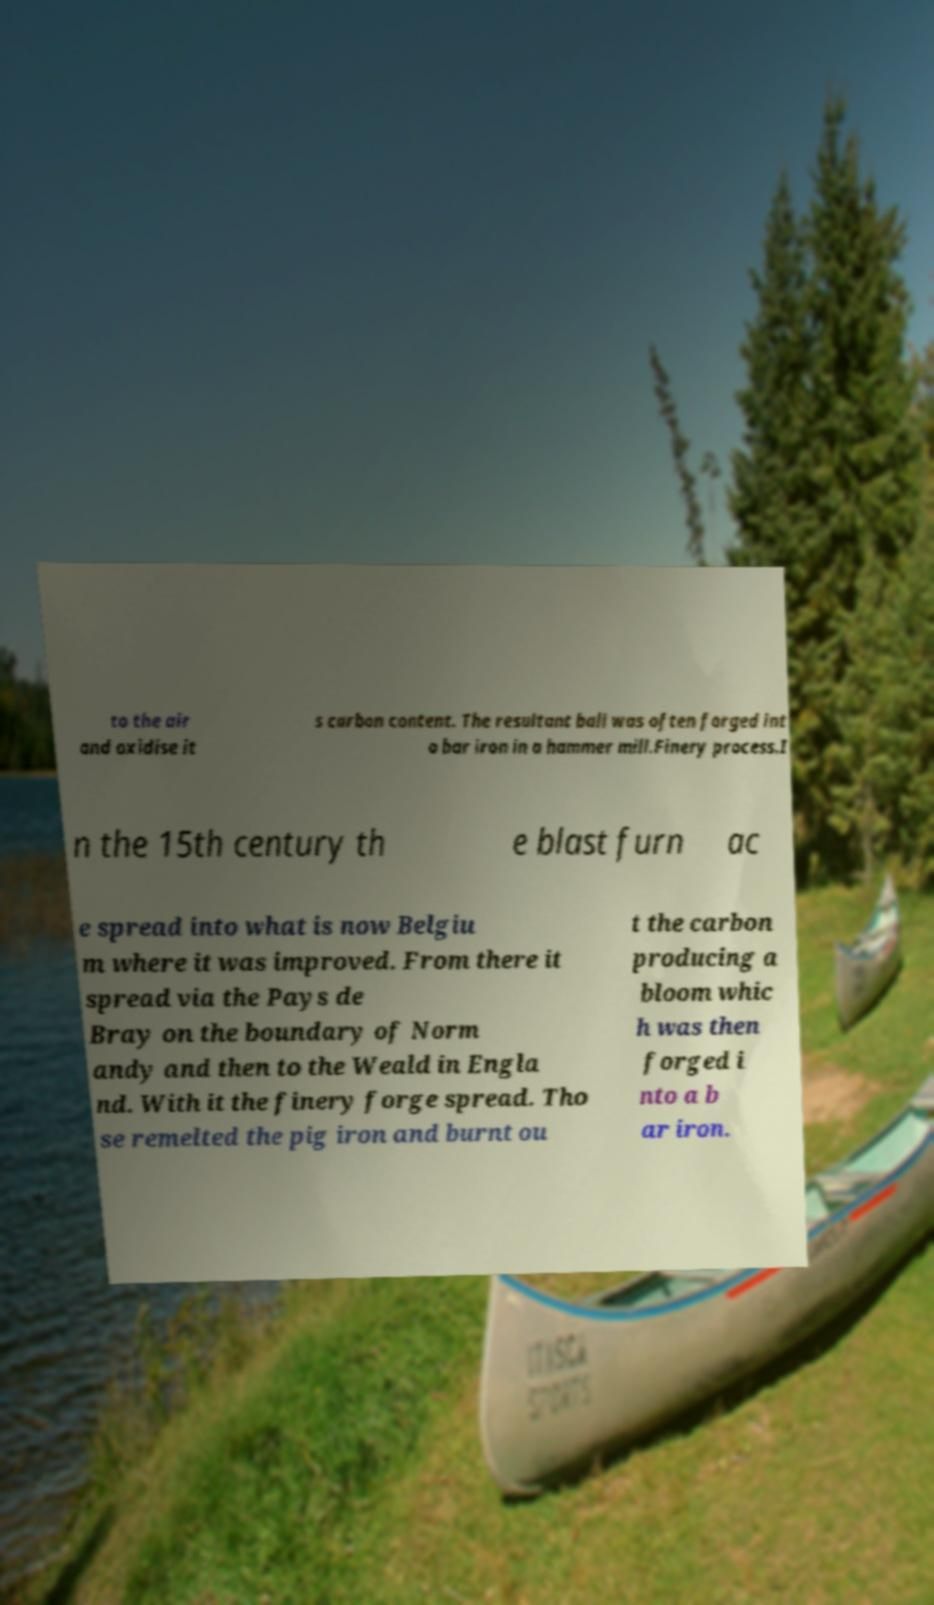There's text embedded in this image that I need extracted. Can you transcribe it verbatim? to the air and oxidise it s carbon content. The resultant ball was often forged int o bar iron in a hammer mill.Finery process.I n the 15th century th e blast furn ac e spread into what is now Belgiu m where it was improved. From there it spread via the Pays de Bray on the boundary of Norm andy and then to the Weald in Engla nd. With it the finery forge spread. Tho se remelted the pig iron and burnt ou t the carbon producing a bloom whic h was then forged i nto a b ar iron. 